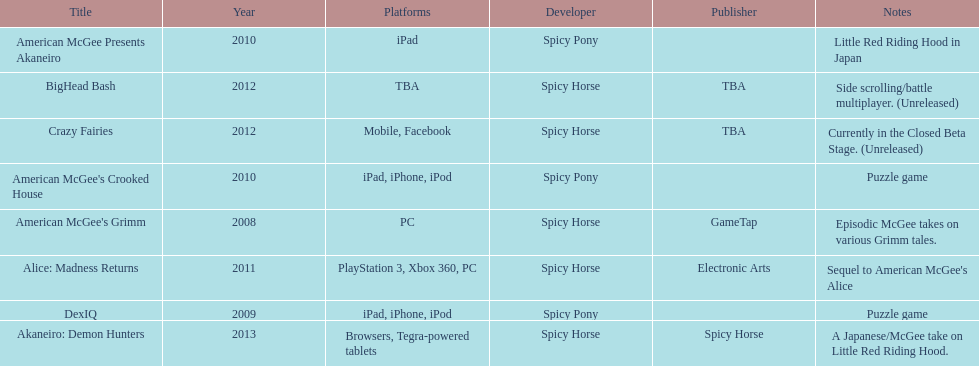What platform was used for the last title on this chart? Browsers, Tegra-powered tablets. 